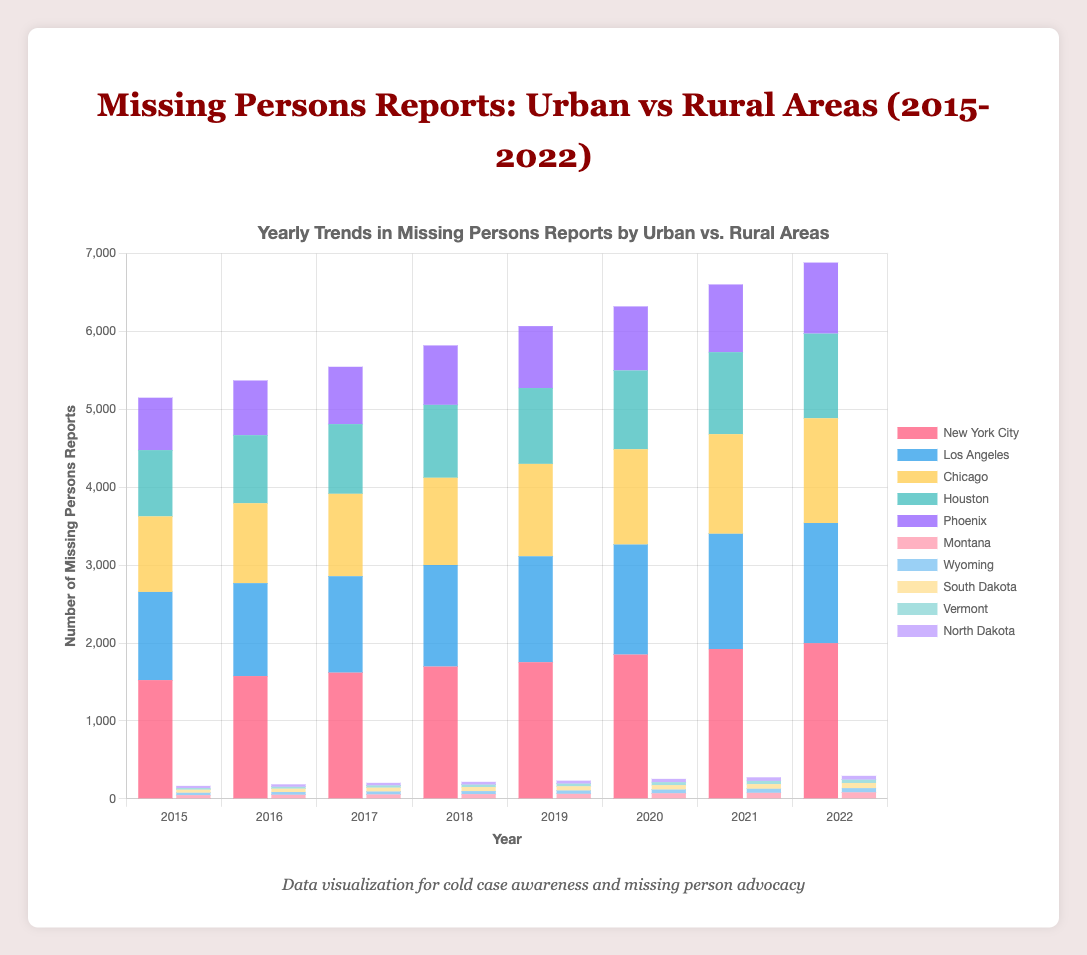What was the total number of missing persons reports in urban areas in 2015? Add the reports for New York City, Los Angeles, Chicago, Houston, and Phoenix in 2015. (1524 + 1132 + 970 + 851 + 673) = 5150
Answer: 5150 Which year saw the highest number of missing persons reports in New York City? Look at the yearly data and find the year where New York City has the highest bar (1998 in 2022)
Answer: 2022 How did the number of missing persons reports in rural Montana change from 2015 to 2022? Subtract the number of reports in 2015 from the number in 2022 for Montana. (83 - 47) = 36
Answer: 36 Compare the overall trends in urban and rural missing persons reports from 2015 to 2022. Notice that urban reports generally show a steady increase, while the increase in rural reports is much lower and less consistent.
Answer: Urban reports increased steadily, rural reports increased slightly but inconsistently In 2020, how many more missing persons reports were there in Los Angeles compared to Phoenix? Subtract the number of reports in Phoenix from the number in Los Angeles in 2020. (1413 - 822) = 591
Answer: 591 Which rural area had the smallest number of missing persons reports each year from 2015 to 2022? Find the smallest value in the rural section for each year. Vermont has the smallest value every year.
Answer: Vermont What is the average number of missing persons reports in Chicago across the given years? Add the number of reports in Chicago for all the years and divide by the number of years. (970 + 1026 + 1058 + 1120 + 1186 + 1223 + 1279 + 1345) / 8 = 1151.125
Answer: 1151.125 How does the total number of missing persons reports in urban areas in 2022 compare to that in rural areas the same year? Add up the urban reports and the rural reports for 2022, then compare them. Urban total: (1998 + 1543 + 1345 + 1087 + 912) = 6885, Rural total: (83 + 54 + 66 + 43 + 49) = 295. Urban reports are much higher (6885 - 295 = 6590).
Answer: Urban reports are much higher by 6590 